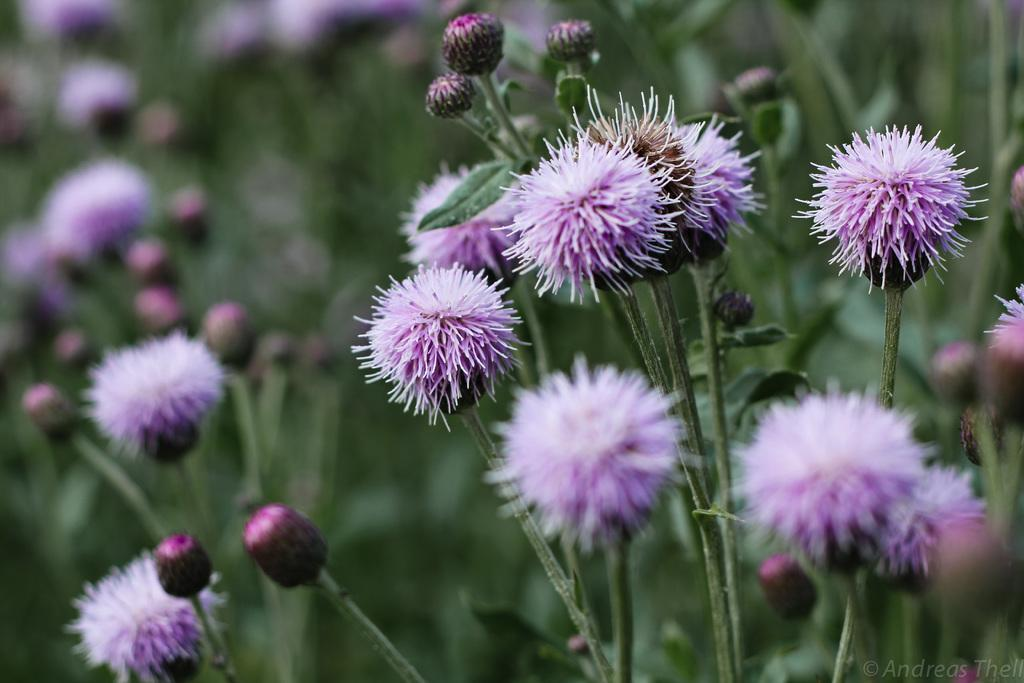What type of plants can be seen in the image? There are plants with flowers and plants with buds in the image. What is the color of the flowers and buds? The flowers and buds are violet in color. What type of patch is visible on the partner's arm in the image? There is no partner or patch present in the image; it features plants with flowers and buds. 